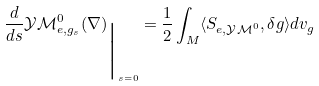<formula> <loc_0><loc_0><loc_500><loc_500>\frac { d } { d s } \mathcal { Y M } _ { e , g _ { s } } ^ { 0 } ( { \nabla } ) _ { \Big { | } _ { s = 0 } } & = \frac { 1 } { 2 } \int _ { M } \langle S _ { e , \mathcal { Y M } ^ { 0 } } , \delta g \rangle d v _ { g } \\</formula> 